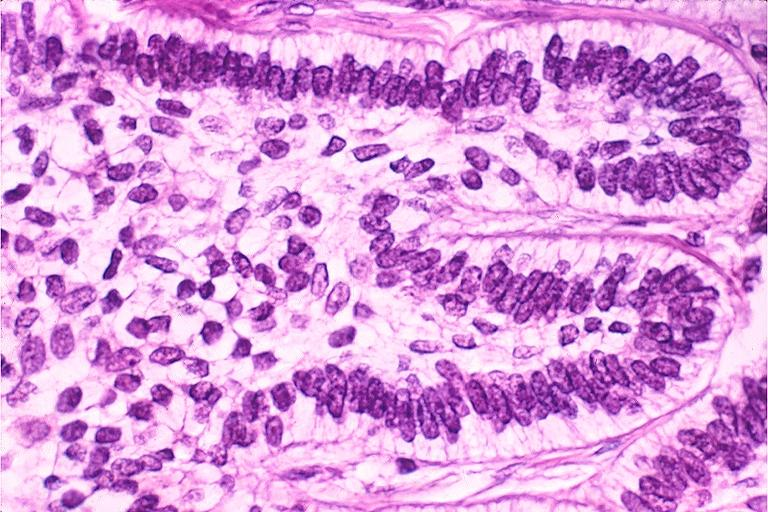does this image show ameloblastoma?
Answer the question using a single word or phrase. Yes 